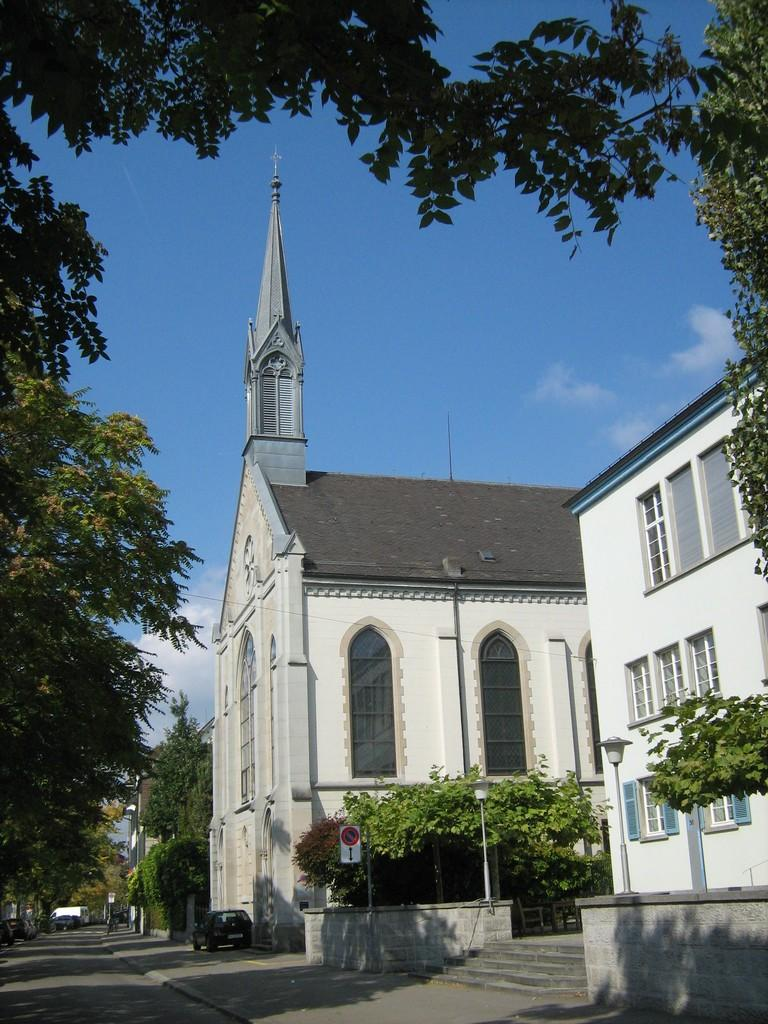What is the main feature of the image? There is a road in the image. What else can be seen on the road? There is a vehicle in the image. What is present near the road? There is a signboard and light poles in the image. What type of vegetation is visible in the image? There are trees in the image. What type of structures can be seen in the image? There are buildings with windows in the image. What other objects are present in the image? There are some objects in the image. What can be seen in the background of the image? The sky is visible in the background of the image. What type of pie is being served in the image? There is no pie present in the image. Can you tell me how many eyes are visible in the image? There are no eyes visible in the image. 